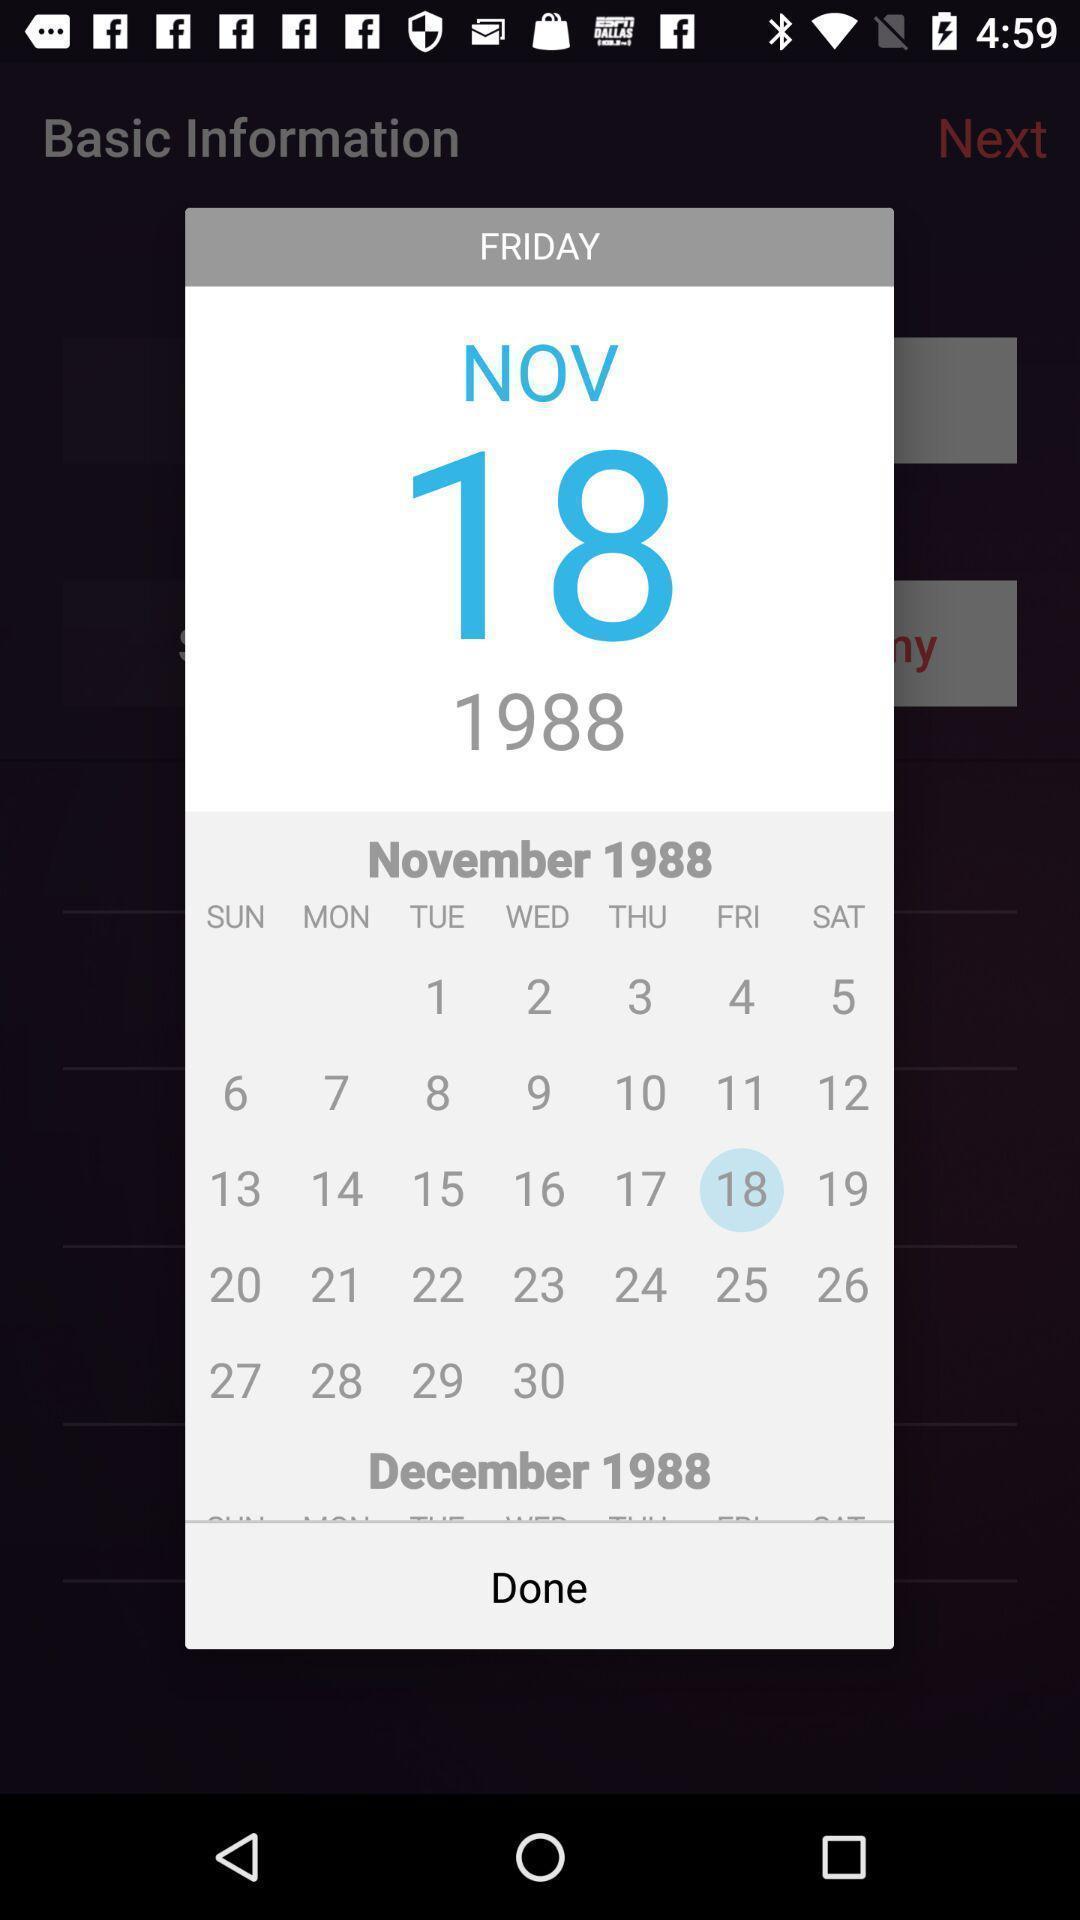Give me a summary of this screen capture. Pop-up showing to select date in a calendar. 